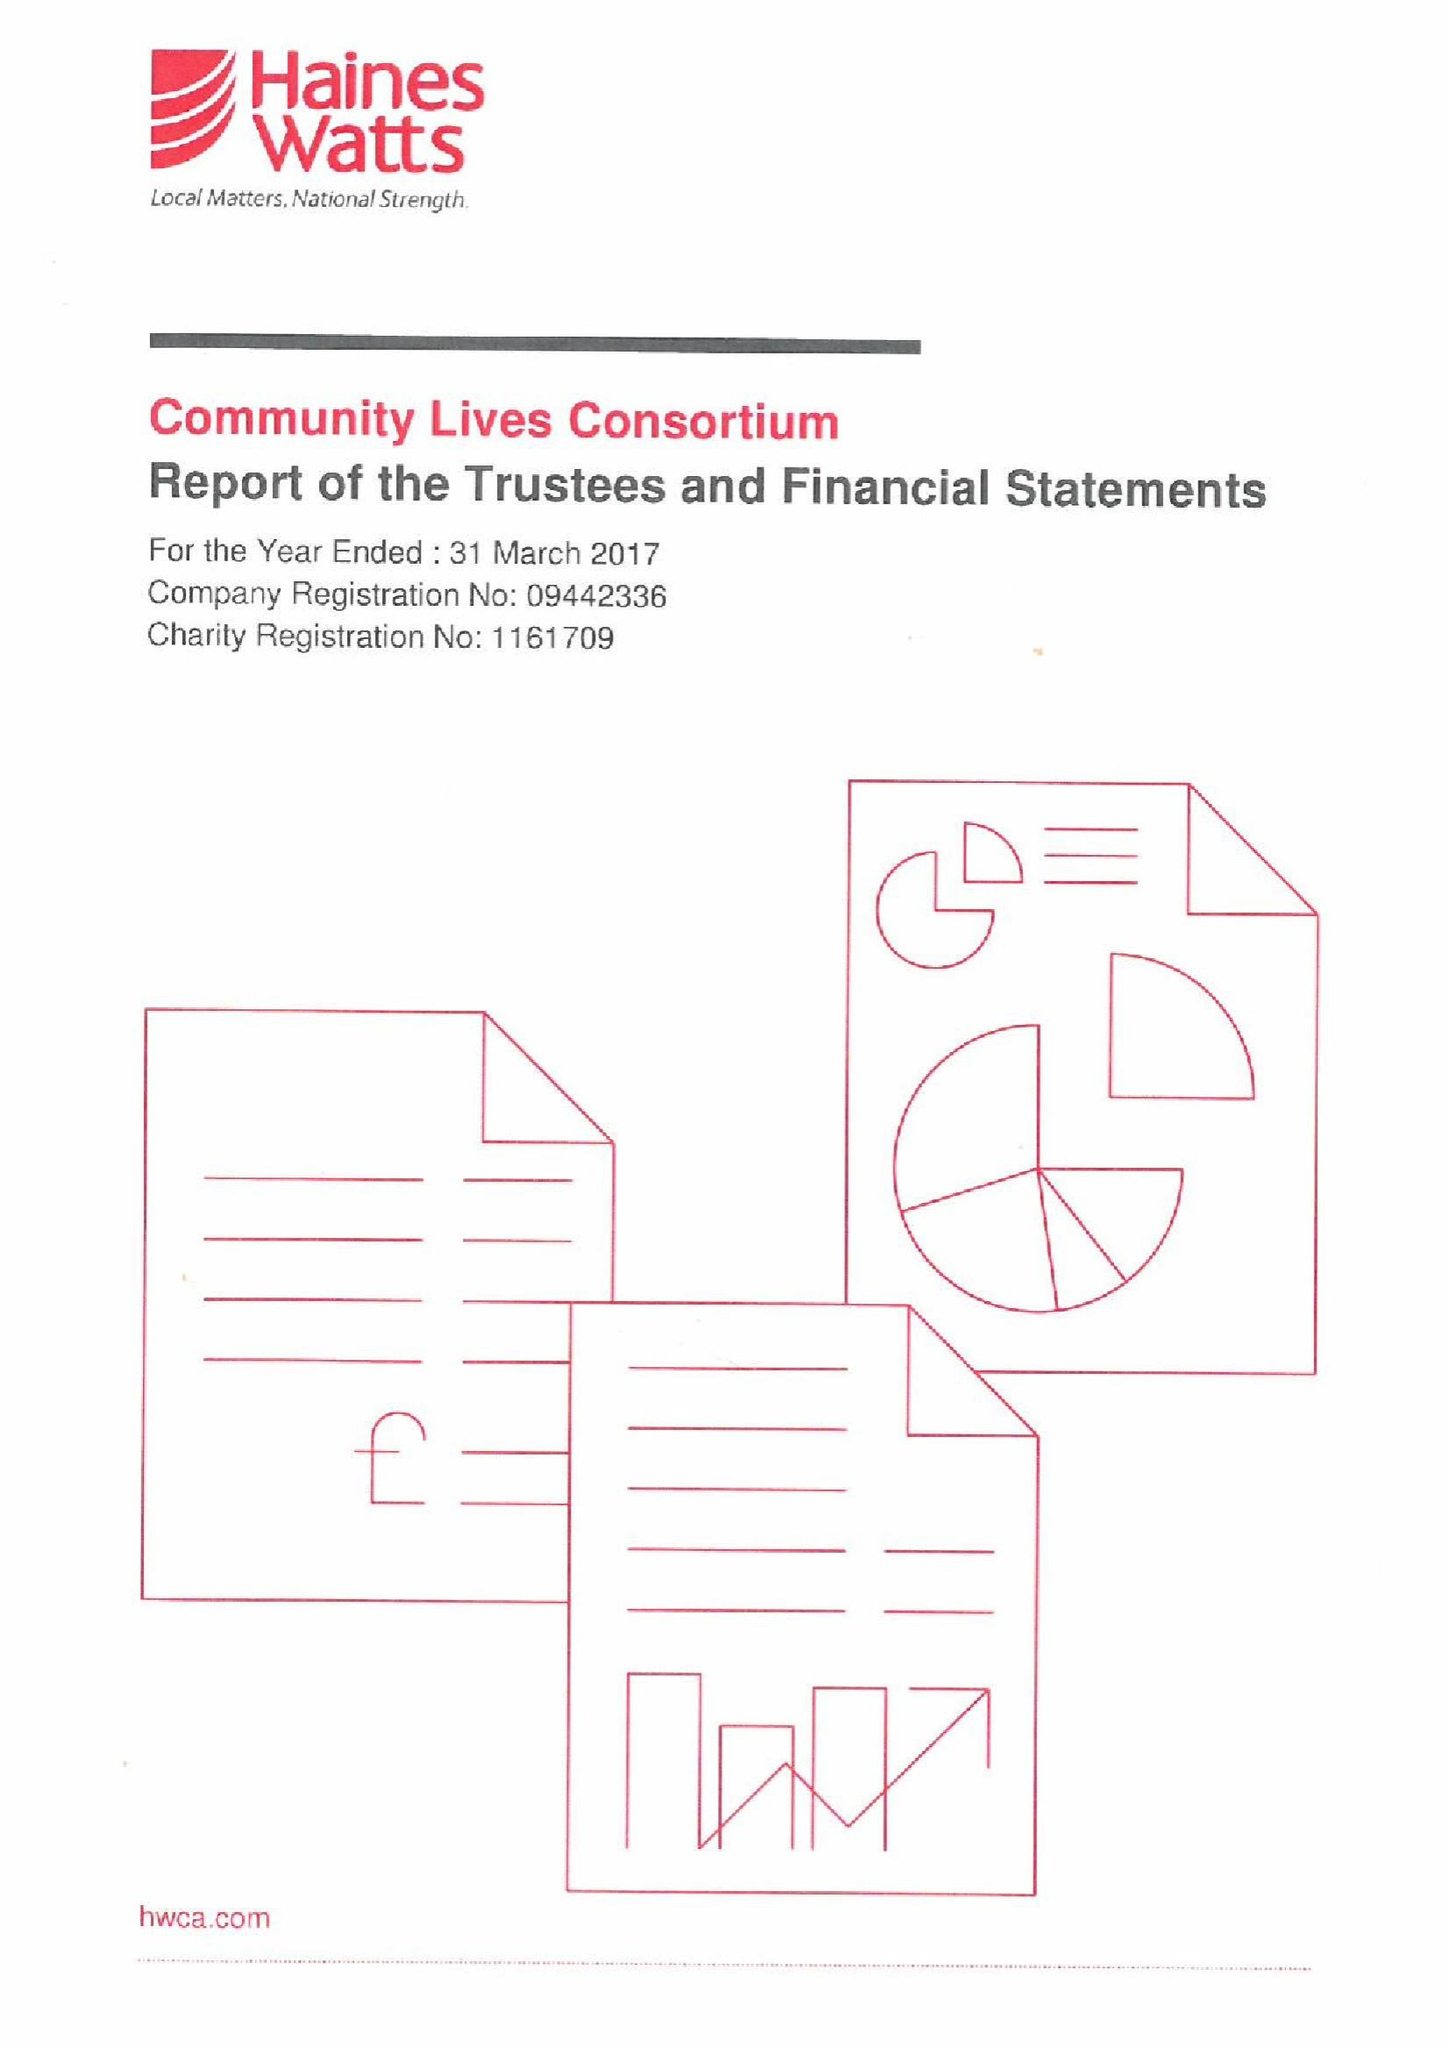What is the value for the address__street_line?
Answer the question using a single word or phrase. 24 WALTER ROAD 